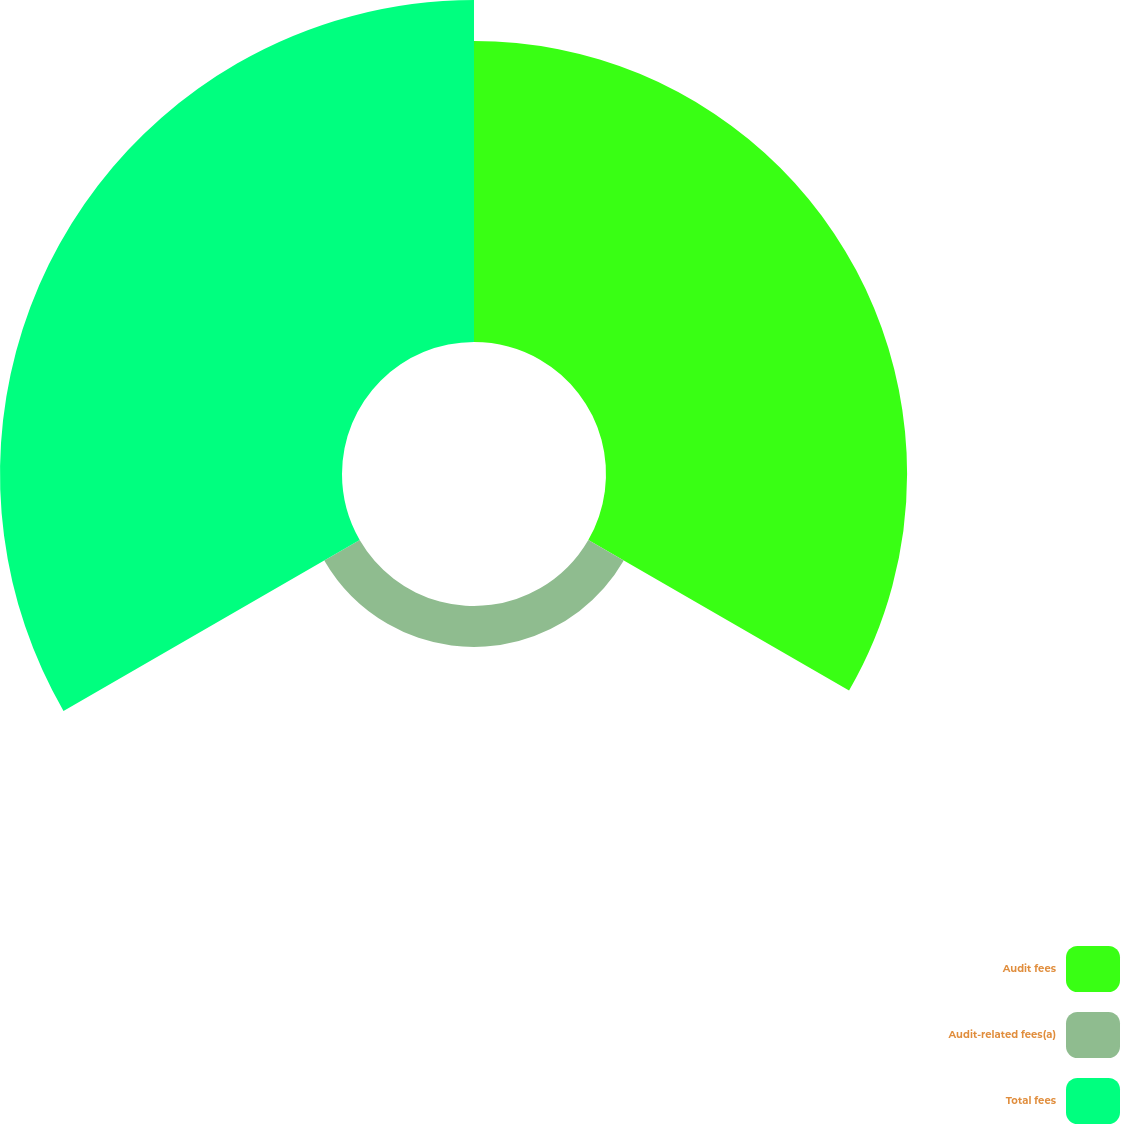Convert chart to OTSL. <chart><loc_0><loc_0><loc_500><loc_500><pie_chart><fcel>Audit fees<fcel>Audit-related fees(a)<fcel>Total fees<nl><fcel>44.02%<fcel>5.98%<fcel>50.0%<nl></chart> 